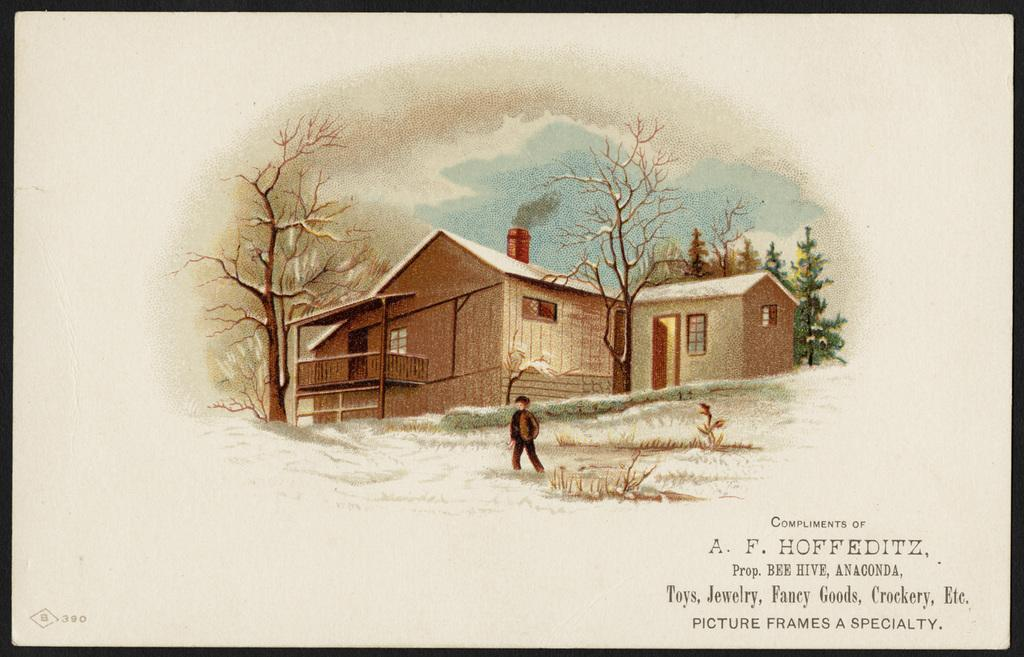What is the main subject of the image? The image contains a painting. What is happening in the painting? A person is standing on the grassland in the painting. What can be seen in the background of the painting? There are trees behind the person, buildings behind the trees, and the sky is visible at the top of the painting. Is there any text in the painting? Yes, there is some text at the right bottom of the painting. What type of thread is being used by the person in the painting? There is no thread present in the painting; the person is standing on the grassland. 